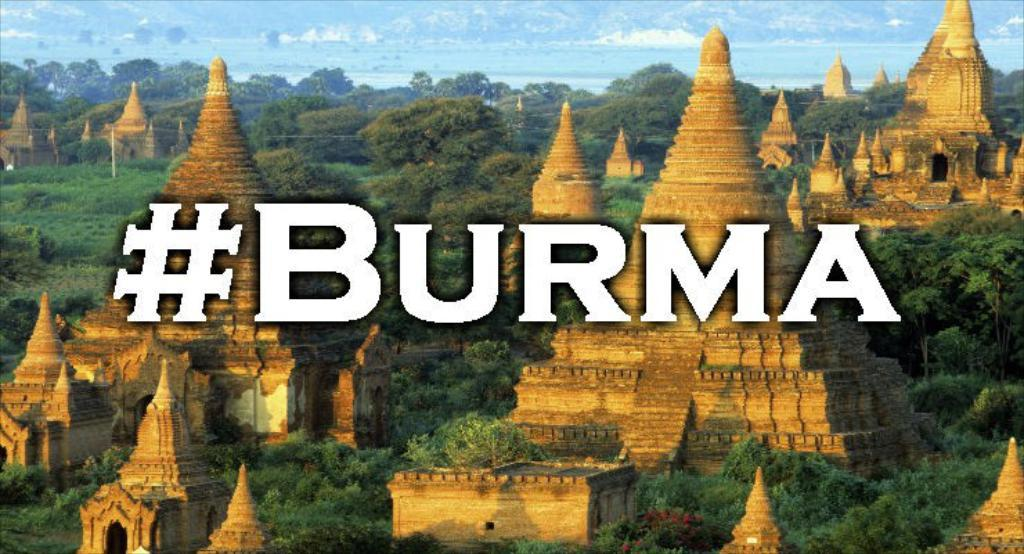What type of structures can be seen in the image? There are many temples in the image. What other natural elements are present in the image? There are trees and plants in the image. What can be seen in the background of the image? The sky is visible in the background of the image. Is there any text present in the image? Yes, the text "BURMA" is written in the image. Can you see any jellyfish swimming in the image? No, there are no jellyfish present in the image. Is there any indication that someone has been bitten by a creature in the image? There is no indication of any creature bites or injuries in the image. 